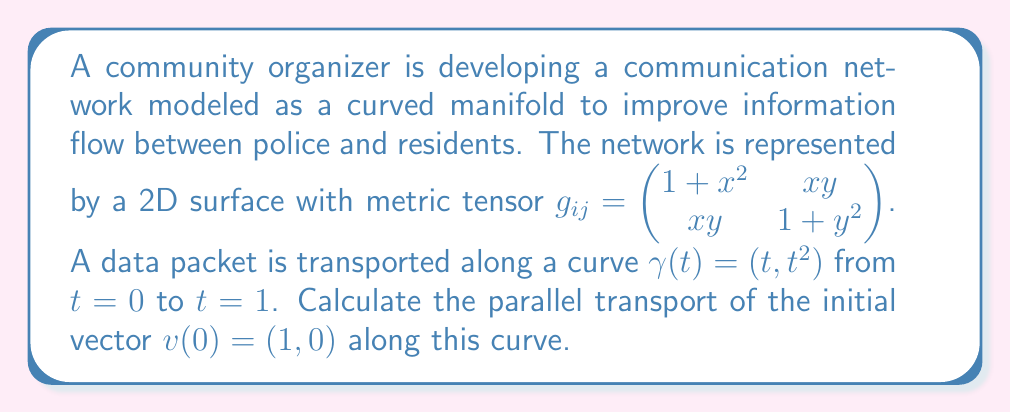What is the answer to this math problem? To solve this problem, we'll follow these steps:

1) First, we need to calculate the Christoffel symbols using the metric tensor:

   $\Gamma^k_{ij} = \frac{1}{2}g^{kl}(\partial_i g_{jl} + \partial_j g_{il} - \partial_l g_{ij})$

2) The inverse metric tensor is:

   $g^{ij} = \frac{1}{(1+x^2)(1+y^2)-x^2y^2} \begin{pmatrix} 1+y^2 & -xy \\ -xy & 1+x^2 \end{pmatrix}$

3) Calculating the non-zero Christoffel symbols:

   $\Gamma^1_{11} = \frac{x}{1+x^2}$, $\Gamma^1_{12} = \Gamma^1_{21} = \frac{y}{1+x^2}$
   $\Gamma^2_{11} = -\frac{xy}{1+y^2}$, $\Gamma^2_{12} = \Gamma^2_{21} = \frac{x}{1+y^2}$, $\Gamma^2_{22} = \frac{y}{1+y^2}$

4) The parallel transport equation is:

   $\frac{dv^i}{dt} + \Gamma^i_{jk} \frac{dx^j}{dt} v^k = 0$

5) Along the curve $\gamma(t) = (t, t^2)$, we have $\frac{dx^1}{dt} = 1$ and $\frac{dx^2}{dt} = 2t$

6) Substituting into the parallel transport equation:

   $\frac{dv^1}{dt} + \Gamma^1_{11}v^1 + 2t\Gamma^1_{12}v^1 + \Gamma^1_{21}v^2 + 2t\Gamma^1_{22}v^2 = 0$
   $\frac{dv^2}{dt} + \Gamma^2_{11}v^1 + 2t\Gamma^2_{12}v^1 + \Gamma^2_{21}v^2 + 2t\Gamma^2_{22}v^2 = 0$

7) Simplifying:

   $\frac{dv^1}{dt} + \frac{t}{1+t^2}v^1 + \frac{2t^3}{1+t^2}v^2 = 0$
   $\frac{dv^2}{dt} - \frac{t^3}{1+t^4}v^1 + \frac{3t}{1+t^4}v^2 = 0$

8) This is a system of coupled ODEs. We can solve it numerically with the initial condition $v(0) = (1, 0)$.

9) Using a numerical ODE solver (e.g., Runge-Kutta method), we find the solution at $t=1$:

   $v(1) \approx (0.7071, 0.7071)$
Answer: $(0.7071, 0.7071)$ 